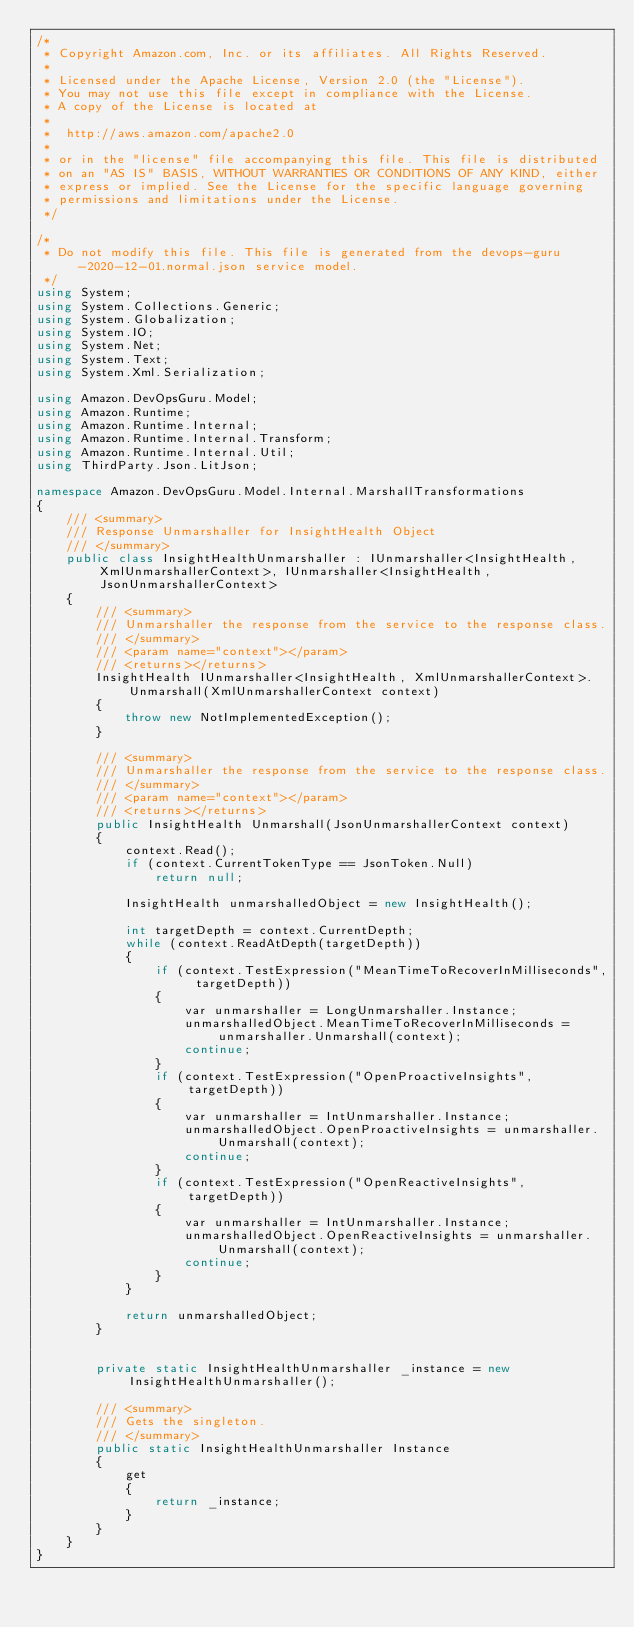<code> <loc_0><loc_0><loc_500><loc_500><_C#_>/*
 * Copyright Amazon.com, Inc. or its affiliates. All Rights Reserved.
 * 
 * Licensed under the Apache License, Version 2.0 (the "License").
 * You may not use this file except in compliance with the License.
 * A copy of the License is located at
 * 
 *  http://aws.amazon.com/apache2.0
 * 
 * or in the "license" file accompanying this file. This file is distributed
 * on an "AS IS" BASIS, WITHOUT WARRANTIES OR CONDITIONS OF ANY KIND, either
 * express or implied. See the License for the specific language governing
 * permissions and limitations under the License.
 */

/*
 * Do not modify this file. This file is generated from the devops-guru-2020-12-01.normal.json service model.
 */
using System;
using System.Collections.Generic;
using System.Globalization;
using System.IO;
using System.Net;
using System.Text;
using System.Xml.Serialization;

using Amazon.DevOpsGuru.Model;
using Amazon.Runtime;
using Amazon.Runtime.Internal;
using Amazon.Runtime.Internal.Transform;
using Amazon.Runtime.Internal.Util;
using ThirdParty.Json.LitJson;

namespace Amazon.DevOpsGuru.Model.Internal.MarshallTransformations
{
    /// <summary>
    /// Response Unmarshaller for InsightHealth Object
    /// </summary>  
    public class InsightHealthUnmarshaller : IUnmarshaller<InsightHealth, XmlUnmarshallerContext>, IUnmarshaller<InsightHealth, JsonUnmarshallerContext>
    {
        /// <summary>
        /// Unmarshaller the response from the service to the response class.
        /// </summary>  
        /// <param name="context"></param>
        /// <returns></returns>
        InsightHealth IUnmarshaller<InsightHealth, XmlUnmarshallerContext>.Unmarshall(XmlUnmarshallerContext context)
        {
            throw new NotImplementedException();
        }

        /// <summary>
        /// Unmarshaller the response from the service to the response class.
        /// </summary>  
        /// <param name="context"></param>
        /// <returns></returns>
        public InsightHealth Unmarshall(JsonUnmarshallerContext context)
        {
            context.Read();
            if (context.CurrentTokenType == JsonToken.Null) 
                return null;

            InsightHealth unmarshalledObject = new InsightHealth();
        
            int targetDepth = context.CurrentDepth;
            while (context.ReadAtDepth(targetDepth))
            {
                if (context.TestExpression("MeanTimeToRecoverInMilliseconds", targetDepth))
                {
                    var unmarshaller = LongUnmarshaller.Instance;
                    unmarshalledObject.MeanTimeToRecoverInMilliseconds = unmarshaller.Unmarshall(context);
                    continue;
                }
                if (context.TestExpression("OpenProactiveInsights", targetDepth))
                {
                    var unmarshaller = IntUnmarshaller.Instance;
                    unmarshalledObject.OpenProactiveInsights = unmarshaller.Unmarshall(context);
                    continue;
                }
                if (context.TestExpression("OpenReactiveInsights", targetDepth))
                {
                    var unmarshaller = IntUnmarshaller.Instance;
                    unmarshalledObject.OpenReactiveInsights = unmarshaller.Unmarshall(context);
                    continue;
                }
            }
          
            return unmarshalledObject;
        }


        private static InsightHealthUnmarshaller _instance = new InsightHealthUnmarshaller();        

        /// <summary>
        /// Gets the singleton.
        /// </summary>  
        public static InsightHealthUnmarshaller Instance
        {
            get
            {
                return _instance;
            }
        }
    }
}</code> 